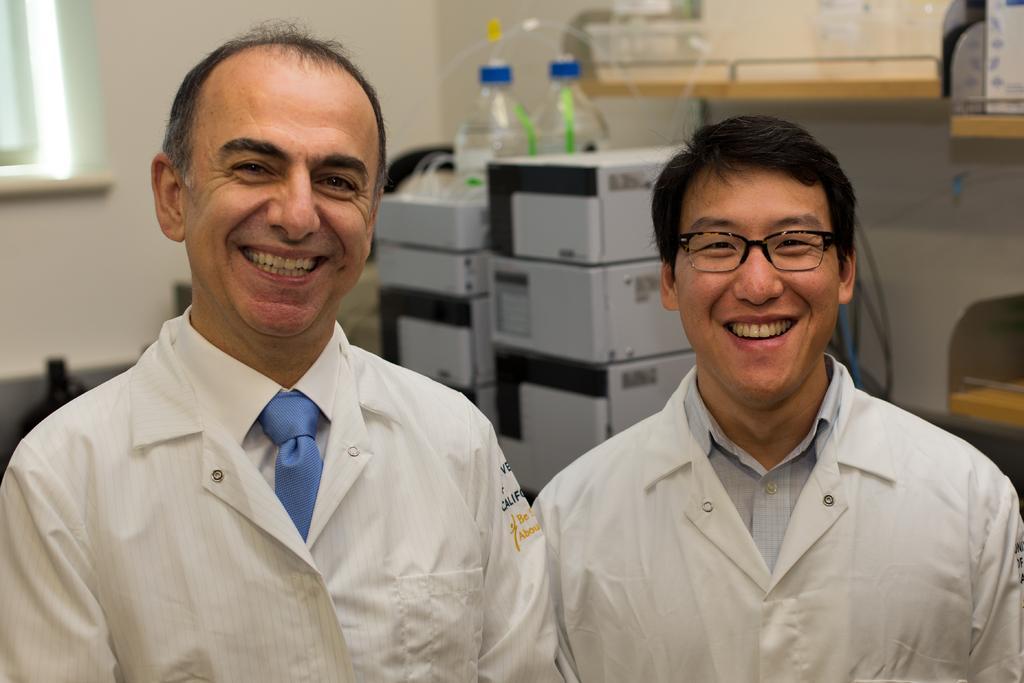In one or two sentences, can you explain what this image depicts? In this picture we can see two men smiling were a man wore a spectacle and in the background we can see boxes, bottles, wall and some objects. 